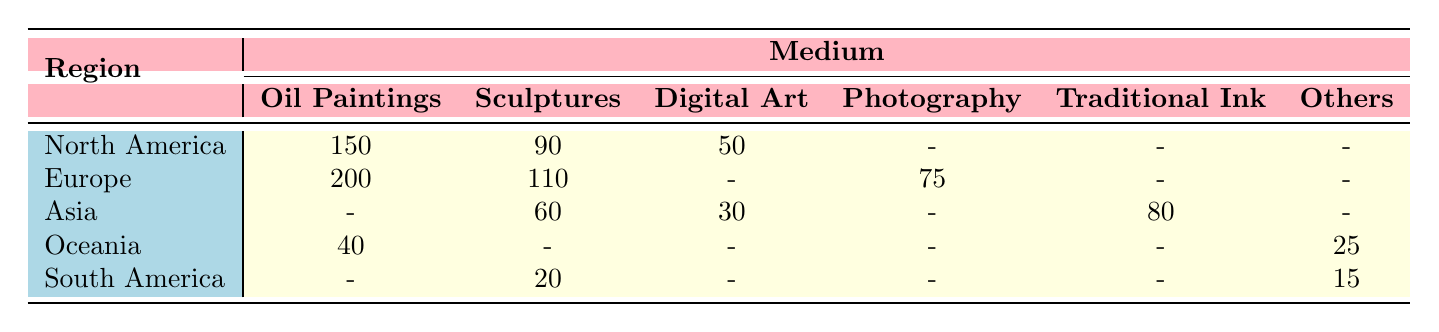What is the total sales of Oil Paintings in North America? The table shows that the sales of Oil Paintings in North America is 150 million USD.
Answer: 150 million USD Which region sold the highest amount of Sculptures? By looking at the Sculptures row, Europe has the highest sales of 110 million USD, compared to other regions.
Answer: Europe What is the combined sales of Digital Art across all regions? The sales of Digital Art from North America is 50 million USD, from Asia is 30 million USD, and there is no sales from other regions. Adding these gives 50 + 30 = 80 million USD.
Answer: 80 million USD Was the sales of Traditional Ink reported in any region? According to the table, Traditional Ink is only reported in Asia, with total sales of 80 million USD, indicating it exists.
Answer: Yes Which region has the lowest sales in any medium? South America has the lowest sales in the medium of Street Art, totaling 15 million USD, which is lower than any sales figures for other regions.
Answer: South America What is the average sales of Sculptures across all regions? The sales of Sculptures are 90 million USD (North America), 110 million USD (Europe), 60 million USD (Asia), and 20 million USD (South America). Adding these gives 90 + 110 + 60 + 20 = 280 million USD. Dividing this by 4 regions gives an average of 280 / 4 = 70 million USD.
Answer: 70 million USD Is there any region that sold more than 200 million USD in total sales? To check this, we add the sales for all mediums in each region. North America totals 290 (150 + 90 + 50), Europe totals 385 (200 + 110 + 75), Asia totals 170 (80 + 60 + 30), Oceania totals 65 (40 + 25), and South America totals 35 (15 + 20). Only Europe exceeds 200 million USD.
Answer: Yes What percentage of total sales in Europe came from Oil Paintings? In Europe, total sales are 385 million USD (200 from Oil Paintings, 110 from Sculptures, and 75 from Photography). To find the percentage from Oil Paintings: (200 / 385) * 100 = approximately 51.95%.
Answer: Approximately 51.95% 